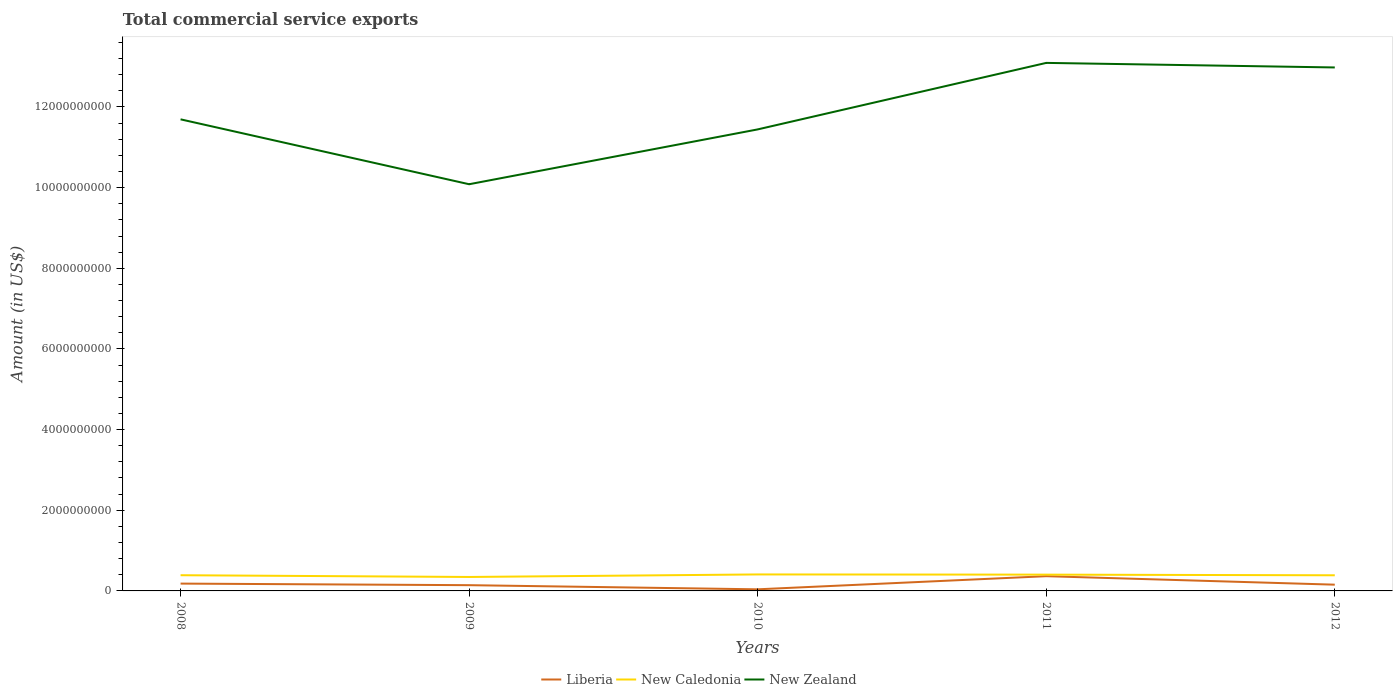Does the line corresponding to New Zealand intersect with the line corresponding to Liberia?
Keep it short and to the point. No. Across all years, what is the maximum total commercial service exports in New Zealand?
Make the answer very short. 1.01e+1. What is the total total commercial service exports in Liberia in the graph?
Your response must be concise. -3.26e+08. What is the difference between the highest and the second highest total commercial service exports in Liberia?
Your answer should be very brief. 3.26e+08. What is the difference between the highest and the lowest total commercial service exports in New Zealand?
Keep it short and to the point. 2. Is the total commercial service exports in New Caledonia strictly greater than the total commercial service exports in Liberia over the years?
Provide a short and direct response. No. How many years are there in the graph?
Ensure brevity in your answer.  5. Does the graph contain any zero values?
Your answer should be very brief. No. Does the graph contain grids?
Offer a terse response. No. How many legend labels are there?
Provide a short and direct response. 3. What is the title of the graph?
Make the answer very short. Total commercial service exports. Does "High income: nonOECD" appear as one of the legend labels in the graph?
Your response must be concise. No. What is the Amount (in US$) in Liberia in 2008?
Offer a terse response. 1.82e+08. What is the Amount (in US$) of New Caledonia in 2008?
Give a very brief answer. 3.89e+08. What is the Amount (in US$) in New Zealand in 2008?
Give a very brief answer. 1.17e+1. What is the Amount (in US$) of Liberia in 2009?
Provide a succinct answer. 1.42e+08. What is the Amount (in US$) in New Caledonia in 2009?
Your answer should be very brief. 3.46e+08. What is the Amount (in US$) in New Zealand in 2009?
Your response must be concise. 1.01e+1. What is the Amount (in US$) in Liberia in 2010?
Your response must be concise. 3.98e+07. What is the Amount (in US$) in New Caledonia in 2010?
Your answer should be compact. 4.09e+08. What is the Amount (in US$) in New Zealand in 2010?
Your answer should be compact. 1.14e+1. What is the Amount (in US$) of Liberia in 2011?
Your response must be concise. 3.65e+08. What is the Amount (in US$) in New Caledonia in 2011?
Provide a succinct answer. 4.04e+08. What is the Amount (in US$) of New Zealand in 2011?
Provide a succinct answer. 1.31e+1. What is the Amount (in US$) in Liberia in 2012?
Keep it short and to the point. 1.55e+08. What is the Amount (in US$) of New Caledonia in 2012?
Your answer should be very brief. 3.88e+08. What is the Amount (in US$) of New Zealand in 2012?
Offer a terse response. 1.30e+1. Across all years, what is the maximum Amount (in US$) in Liberia?
Your answer should be very brief. 3.65e+08. Across all years, what is the maximum Amount (in US$) in New Caledonia?
Keep it short and to the point. 4.09e+08. Across all years, what is the maximum Amount (in US$) in New Zealand?
Give a very brief answer. 1.31e+1. Across all years, what is the minimum Amount (in US$) in Liberia?
Provide a short and direct response. 3.98e+07. Across all years, what is the minimum Amount (in US$) of New Caledonia?
Offer a very short reply. 3.46e+08. Across all years, what is the minimum Amount (in US$) in New Zealand?
Provide a succinct answer. 1.01e+1. What is the total Amount (in US$) in Liberia in the graph?
Make the answer very short. 8.84e+08. What is the total Amount (in US$) of New Caledonia in the graph?
Make the answer very short. 1.94e+09. What is the total Amount (in US$) in New Zealand in the graph?
Provide a succinct answer. 5.93e+1. What is the difference between the Amount (in US$) in Liberia in 2008 and that in 2009?
Your response must be concise. 3.93e+07. What is the difference between the Amount (in US$) in New Caledonia in 2008 and that in 2009?
Provide a short and direct response. 4.31e+07. What is the difference between the Amount (in US$) of New Zealand in 2008 and that in 2009?
Your response must be concise. 1.61e+09. What is the difference between the Amount (in US$) of Liberia in 2008 and that in 2010?
Keep it short and to the point. 1.42e+08. What is the difference between the Amount (in US$) in New Caledonia in 2008 and that in 2010?
Keep it short and to the point. -1.97e+07. What is the difference between the Amount (in US$) in New Zealand in 2008 and that in 2010?
Make the answer very short. 2.50e+08. What is the difference between the Amount (in US$) in Liberia in 2008 and that in 2011?
Your answer should be compact. -1.84e+08. What is the difference between the Amount (in US$) of New Caledonia in 2008 and that in 2011?
Your answer should be very brief. -1.45e+07. What is the difference between the Amount (in US$) in New Zealand in 2008 and that in 2011?
Give a very brief answer. -1.40e+09. What is the difference between the Amount (in US$) of Liberia in 2008 and that in 2012?
Offer a very short reply. 2.68e+07. What is the difference between the Amount (in US$) in New Caledonia in 2008 and that in 2012?
Offer a terse response. 1.44e+06. What is the difference between the Amount (in US$) of New Zealand in 2008 and that in 2012?
Make the answer very short. -1.29e+09. What is the difference between the Amount (in US$) of Liberia in 2009 and that in 2010?
Provide a succinct answer. 1.03e+08. What is the difference between the Amount (in US$) of New Caledonia in 2009 and that in 2010?
Your answer should be compact. -6.27e+07. What is the difference between the Amount (in US$) of New Zealand in 2009 and that in 2010?
Keep it short and to the point. -1.36e+09. What is the difference between the Amount (in US$) in Liberia in 2009 and that in 2011?
Give a very brief answer. -2.23e+08. What is the difference between the Amount (in US$) of New Caledonia in 2009 and that in 2011?
Your response must be concise. -5.76e+07. What is the difference between the Amount (in US$) of New Zealand in 2009 and that in 2011?
Ensure brevity in your answer.  -3.01e+09. What is the difference between the Amount (in US$) in Liberia in 2009 and that in 2012?
Provide a short and direct response. -1.25e+07. What is the difference between the Amount (in US$) in New Caledonia in 2009 and that in 2012?
Provide a succinct answer. -4.16e+07. What is the difference between the Amount (in US$) in New Zealand in 2009 and that in 2012?
Offer a very short reply. -2.90e+09. What is the difference between the Amount (in US$) in Liberia in 2010 and that in 2011?
Offer a terse response. -3.26e+08. What is the difference between the Amount (in US$) of New Caledonia in 2010 and that in 2011?
Ensure brevity in your answer.  5.13e+06. What is the difference between the Amount (in US$) in New Zealand in 2010 and that in 2011?
Make the answer very short. -1.65e+09. What is the difference between the Amount (in US$) of Liberia in 2010 and that in 2012?
Make the answer very short. -1.15e+08. What is the difference between the Amount (in US$) in New Caledonia in 2010 and that in 2012?
Keep it short and to the point. 2.11e+07. What is the difference between the Amount (in US$) in New Zealand in 2010 and that in 2012?
Keep it short and to the point. -1.54e+09. What is the difference between the Amount (in US$) of Liberia in 2011 and that in 2012?
Give a very brief answer. 2.10e+08. What is the difference between the Amount (in US$) of New Caledonia in 2011 and that in 2012?
Offer a terse response. 1.60e+07. What is the difference between the Amount (in US$) in New Zealand in 2011 and that in 2012?
Your answer should be very brief. 1.13e+08. What is the difference between the Amount (in US$) of Liberia in 2008 and the Amount (in US$) of New Caledonia in 2009?
Your response must be concise. -1.64e+08. What is the difference between the Amount (in US$) of Liberia in 2008 and the Amount (in US$) of New Zealand in 2009?
Offer a terse response. -9.90e+09. What is the difference between the Amount (in US$) of New Caledonia in 2008 and the Amount (in US$) of New Zealand in 2009?
Keep it short and to the point. -9.69e+09. What is the difference between the Amount (in US$) of Liberia in 2008 and the Amount (in US$) of New Caledonia in 2010?
Provide a succinct answer. -2.27e+08. What is the difference between the Amount (in US$) in Liberia in 2008 and the Amount (in US$) in New Zealand in 2010?
Give a very brief answer. -1.13e+1. What is the difference between the Amount (in US$) of New Caledonia in 2008 and the Amount (in US$) of New Zealand in 2010?
Give a very brief answer. -1.11e+1. What is the difference between the Amount (in US$) of Liberia in 2008 and the Amount (in US$) of New Caledonia in 2011?
Provide a short and direct response. -2.22e+08. What is the difference between the Amount (in US$) in Liberia in 2008 and the Amount (in US$) in New Zealand in 2011?
Offer a very short reply. -1.29e+1. What is the difference between the Amount (in US$) of New Caledonia in 2008 and the Amount (in US$) of New Zealand in 2011?
Make the answer very short. -1.27e+1. What is the difference between the Amount (in US$) of Liberia in 2008 and the Amount (in US$) of New Caledonia in 2012?
Your response must be concise. -2.06e+08. What is the difference between the Amount (in US$) of Liberia in 2008 and the Amount (in US$) of New Zealand in 2012?
Ensure brevity in your answer.  -1.28e+1. What is the difference between the Amount (in US$) of New Caledonia in 2008 and the Amount (in US$) of New Zealand in 2012?
Offer a terse response. -1.26e+1. What is the difference between the Amount (in US$) of Liberia in 2009 and the Amount (in US$) of New Caledonia in 2010?
Your answer should be very brief. -2.66e+08. What is the difference between the Amount (in US$) of Liberia in 2009 and the Amount (in US$) of New Zealand in 2010?
Your answer should be very brief. -1.13e+1. What is the difference between the Amount (in US$) in New Caledonia in 2009 and the Amount (in US$) in New Zealand in 2010?
Provide a short and direct response. -1.11e+1. What is the difference between the Amount (in US$) of Liberia in 2009 and the Amount (in US$) of New Caledonia in 2011?
Give a very brief answer. -2.61e+08. What is the difference between the Amount (in US$) of Liberia in 2009 and the Amount (in US$) of New Zealand in 2011?
Ensure brevity in your answer.  -1.30e+1. What is the difference between the Amount (in US$) in New Caledonia in 2009 and the Amount (in US$) in New Zealand in 2011?
Offer a very short reply. -1.27e+1. What is the difference between the Amount (in US$) of Liberia in 2009 and the Amount (in US$) of New Caledonia in 2012?
Provide a succinct answer. -2.45e+08. What is the difference between the Amount (in US$) in Liberia in 2009 and the Amount (in US$) in New Zealand in 2012?
Offer a terse response. -1.28e+1. What is the difference between the Amount (in US$) of New Caledonia in 2009 and the Amount (in US$) of New Zealand in 2012?
Offer a very short reply. -1.26e+1. What is the difference between the Amount (in US$) of Liberia in 2010 and the Amount (in US$) of New Caledonia in 2011?
Give a very brief answer. -3.64e+08. What is the difference between the Amount (in US$) of Liberia in 2010 and the Amount (in US$) of New Zealand in 2011?
Offer a terse response. -1.31e+1. What is the difference between the Amount (in US$) in New Caledonia in 2010 and the Amount (in US$) in New Zealand in 2011?
Offer a terse response. -1.27e+1. What is the difference between the Amount (in US$) of Liberia in 2010 and the Amount (in US$) of New Caledonia in 2012?
Offer a terse response. -3.48e+08. What is the difference between the Amount (in US$) in Liberia in 2010 and the Amount (in US$) in New Zealand in 2012?
Ensure brevity in your answer.  -1.29e+1. What is the difference between the Amount (in US$) of New Caledonia in 2010 and the Amount (in US$) of New Zealand in 2012?
Your answer should be compact. -1.26e+1. What is the difference between the Amount (in US$) in Liberia in 2011 and the Amount (in US$) in New Caledonia in 2012?
Your answer should be compact. -2.23e+07. What is the difference between the Amount (in US$) in Liberia in 2011 and the Amount (in US$) in New Zealand in 2012?
Your answer should be compact. -1.26e+1. What is the difference between the Amount (in US$) in New Caledonia in 2011 and the Amount (in US$) in New Zealand in 2012?
Make the answer very short. -1.26e+1. What is the average Amount (in US$) of Liberia per year?
Offer a very short reply. 1.77e+08. What is the average Amount (in US$) in New Caledonia per year?
Your response must be concise. 3.87e+08. What is the average Amount (in US$) of New Zealand per year?
Keep it short and to the point. 1.19e+1. In the year 2008, what is the difference between the Amount (in US$) in Liberia and Amount (in US$) in New Caledonia?
Offer a very short reply. -2.07e+08. In the year 2008, what is the difference between the Amount (in US$) of Liberia and Amount (in US$) of New Zealand?
Your answer should be compact. -1.15e+1. In the year 2008, what is the difference between the Amount (in US$) of New Caledonia and Amount (in US$) of New Zealand?
Provide a succinct answer. -1.13e+1. In the year 2009, what is the difference between the Amount (in US$) in Liberia and Amount (in US$) in New Caledonia?
Keep it short and to the point. -2.04e+08. In the year 2009, what is the difference between the Amount (in US$) in Liberia and Amount (in US$) in New Zealand?
Provide a succinct answer. -9.94e+09. In the year 2009, what is the difference between the Amount (in US$) in New Caledonia and Amount (in US$) in New Zealand?
Your response must be concise. -9.74e+09. In the year 2010, what is the difference between the Amount (in US$) in Liberia and Amount (in US$) in New Caledonia?
Keep it short and to the point. -3.69e+08. In the year 2010, what is the difference between the Amount (in US$) of Liberia and Amount (in US$) of New Zealand?
Your answer should be very brief. -1.14e+1. In the year 2010, what is the difference between the Amount (in US$) of New Caledonia and Amount (in US$) of New Zealand?
Make the answer very short. -1.10e+1. In the year 2011, what is the difference between the Amount (in US$) in Liberia and Amount (in US$) in New Caledonia?
Offer a very short reply. -3.83e+07. In the year 2011, what is the difference between the Amount (in US$) in Liberia and Amount (in US$) in New Zealand?
Your answer should be compact. -1.27e+1. In the year 2011, what is the difference between the Amount (in US$) of New Caledonia and Amount (in US$) of New Zealand?
Provide a succinct answer. -1.27e+1. In the year 2012, what is the difference between the Amount (in US$) in Liberia and Amount (in US$) in New Caledonia?
Provide a short and direct response. -2.33e+08. In the year 2012, what is the difference between the Amount (in US$) in Liberia and Amount (in US$) in New Zealand?
Your response must be concise. -1.28e+1. In the year 2012, what is the difference between the Amount (in US$) of New Caledonia and Amount (in US$) of New Zealand?
Keep it short and to the point. -1.26e+1. What is the ratio of the Amount (in US$) in Liberia in 2008 to that in 2009?
Your answer should be compact. 1.28. What is the ratio of the Amount (in US$) of New Caledonia in 2008 to that in 2009?
Offer a very short reply. 1.12. What is the ratio of the Amount (in US$) in New Zealand in 2008 to that in 2009?
Your answer should be compact. 1.16. What is the ratio of the Amount (in US$) in Liberia in 2008 to that in 2010?
Provide a succinct answer. 4.57. What is the ratio of the Amount (in US$) in New Caledonia in 2008 to that in 2010?
Ensure brevity in your answer.  0.95. What is the ratio of the Amount (in US$) in New Zealand in 2008 to that in 2010?
Make the answer very short. 1.02. What is the ratio of the Amount (in US$) of Liberia in 2008 to that in 2011?
Your response must be concise. 0.5. What is the ratio of the Amount (in US$) of New Zealand in 2008 to that in 2011?
Ensure brevity in your answer.  0.89. What is the ratio of the Amount (in US$) in Liberia in 2008 to that in 2012?
Give a very brief answer. 1.17. What is the ratio of the Amount (in US$) of New Zealand in 2008 to that in 2012?
Give a very brief answer. 0.9. What is the ratio of the Amount (in US$) of Liberia in 2009 to that in 2010?
Your answer should be very brief. 3.58. What is the ratio of the Amount (in US$) of New Caledonia in 2009 to that in 2010?
Your answer should be very brief. 0.85. What is the ratio of the Amount (in US$) in New Zealand in 2009 to that in 2010?
Offer a terse response. 0.88. What is the ratio of the Amount (in US$) in Liberia in 2009 to that in 2011?
Offer a terse response. 0.39. What is the ratio of the Amount (in US$) of New Caledonia in 2009 to that in 2011?
Your response must be concise. 0.86. What is the ratio of the Amount (in US$) in New Zealand in 2009 to that in 2011?
Ensure brevity in your answer.  0.77. What is the ratio of the Amount (in US$) in Liberia in 2009 to that in 2012?
Your response must be concise. 0.92. What is the ratio of the Amount (in US$) of New Caledonia in 2009 to that in 2012?
Offer a very short reply. 0.89. What is the ratio of the Amount (in US$) of New Zealand in 2009 to that in 2012?
Your response must be concise. 0.78. What is the ratio of the Amount (in US$) of Liberia in 2010 to that in 2011?
Ensure brevity in your answer.  0.11. What is the ratio of the Amount (in US$) in New Caledonia in 2010 to that in 2011?
Your answer should be very brief. 1.01. What is the ratio of the Amount (in US$) in New Zealand in 2010 to that in 2011?
Provide a succinct answer. 0.87. What is the ratio of the Amount (in US$) of Liberia in 2010 to that in 2012?
Offer a terse response. 0.26. What is the ratio of the Amount (in US$) of New Caledonia in 2010 to that in 2012?
Provide a short and direct response. 1.05. What is the ratio of the Amount (in US$) in New Zealand in 2010 to that in 2012?
Give a very brief answer. 0.88. What is the ratio of the Amount (in US$) in Liberia in 2011 to that in 2012?
Keep it short and to the point. 2.36. What is the ratio of the Amount (in US$) of New Caledonia in 2011 to that in 2012?
Your answer should be compact. 1.04. What is the ratio of the Amount (in US$) in New Zealand in 2011 to that in 2012?
Your answer should be compact. 1.01. What is the difference between the highest and the second highest Amount (in US$) in Liberia?
Make the answer very short. 1.84e+08. What is the difference between the highest and the second highest Amount (in US$) of New Caledonia?
Your response must be concise. 5.13e+06. What is the difference between the highest and the second highest Amount (in US$) of New Zealand?
Make the answer very short. 1.13e+08. What is the difference between the highest and the lowest Amount (in US$) of Liberia?
Offer a terse response. 3.26e+08. What is the difference between the highest and the lowest Amount (in US$) in New Caledonia?
Your answer should be compact. 6.27e+07. What is the difference between the highest and the lowest Amount (in US$) of New Zealand?
Ensure brevity in your answer.  3.01e+09. 